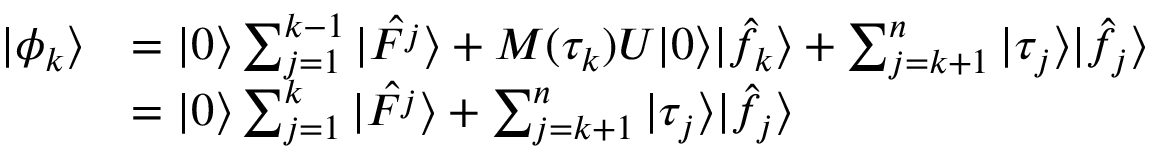Convert formula to latex. <formula><loc_0><loc_0><loc_500><loc_500>\begin{array} { r l } { | \phi _ { k } \rangle } & { = | 0 \rangle \sum _ { j = 1 } ^ { k - 1 } | \hat { F ^ { j } } \rangle + M ( \tau _ { k } ) U | 0 \rangle | \hat { f _ { k } } \rangle + \sum _ { j = k + 1 } ^ { n } | \tau _ { j } \rangle | \hat { f _ { j } } \rangle } \\ & { = | 0 \rangle \sum _ { j = 1 } ^ { k } | \hat { F ^ { j } } \rangle + \sum _ { j = k + 1 } ^ { n } | \tau _ { j } \rangle | \hat { f _ { j } } \rangle } \end{array}</formula> 